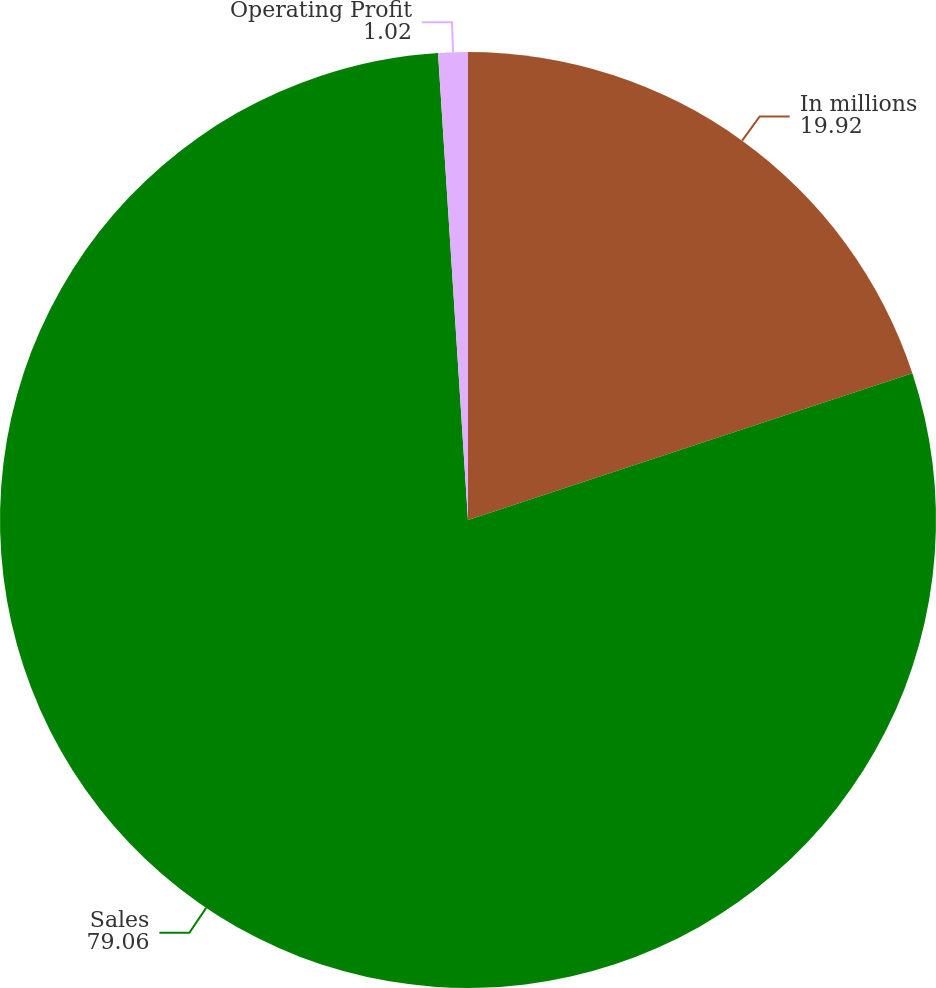Convert chart to OTSL. <chart><loc_0><loc_0><loc_500><loc_500><pie_chart><fcel>In millions<fcel>Sales<fcel>Operating Profit<nl><fcel>19.92%<fcel>79.06%<fcel>1.02%<nl></chart> 